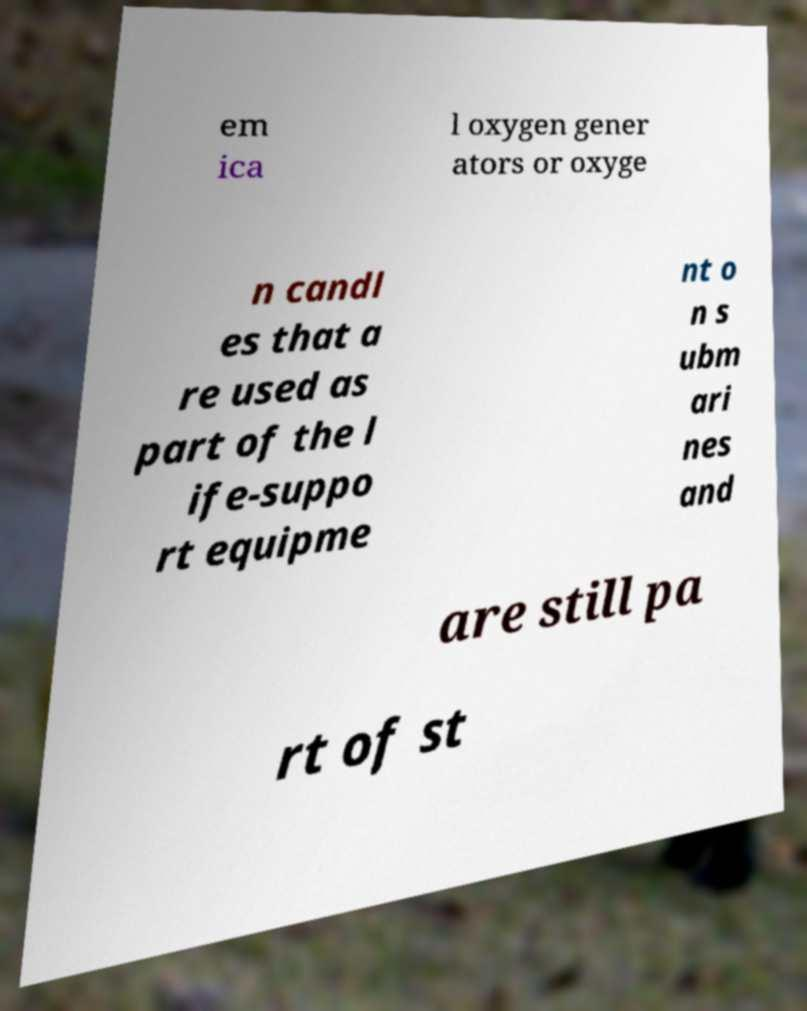Could you extract and type out the text from this image? em ica l oxygen gener ators or oxyge n candl es that a re used as part of the l ife-suppo rt equipme nt o n s ubm ari nes and are still pa rt of st 